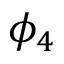<formula> <loc_0><loc_0><loc_500><loc_500>\phi _ { 4 }</formula> 